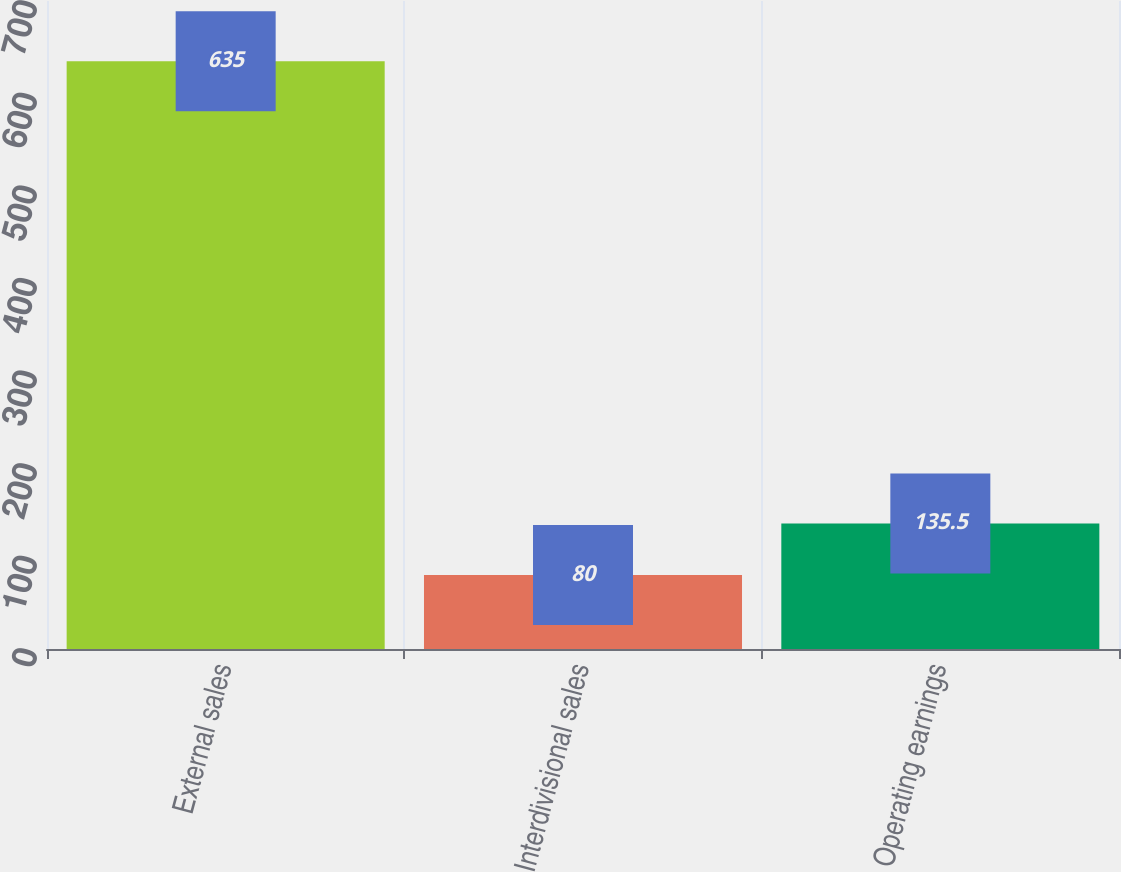Convert chart. <chart><loc_0><loc_0><loc_500><loc_500><bar_chart><fcel>External sales<fcel>Interdivisional sales<fcel>Operating earnings<nl><fcel>635<fcel>80<fcel>135.5<nl></chart> 